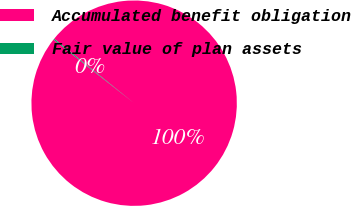Convert chart. <chart><loc_0><loc_0><loc_500><loc_500><pie_chart><fcel>Accumulated benefit obligation<fcel>Fair value of plan assets<nl><fcel>99.84%<fcel>0.16%<nl></chart> 